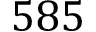<formula> <loc_0><loc_0><loc_500><loc_500>5 8 5</formula> 